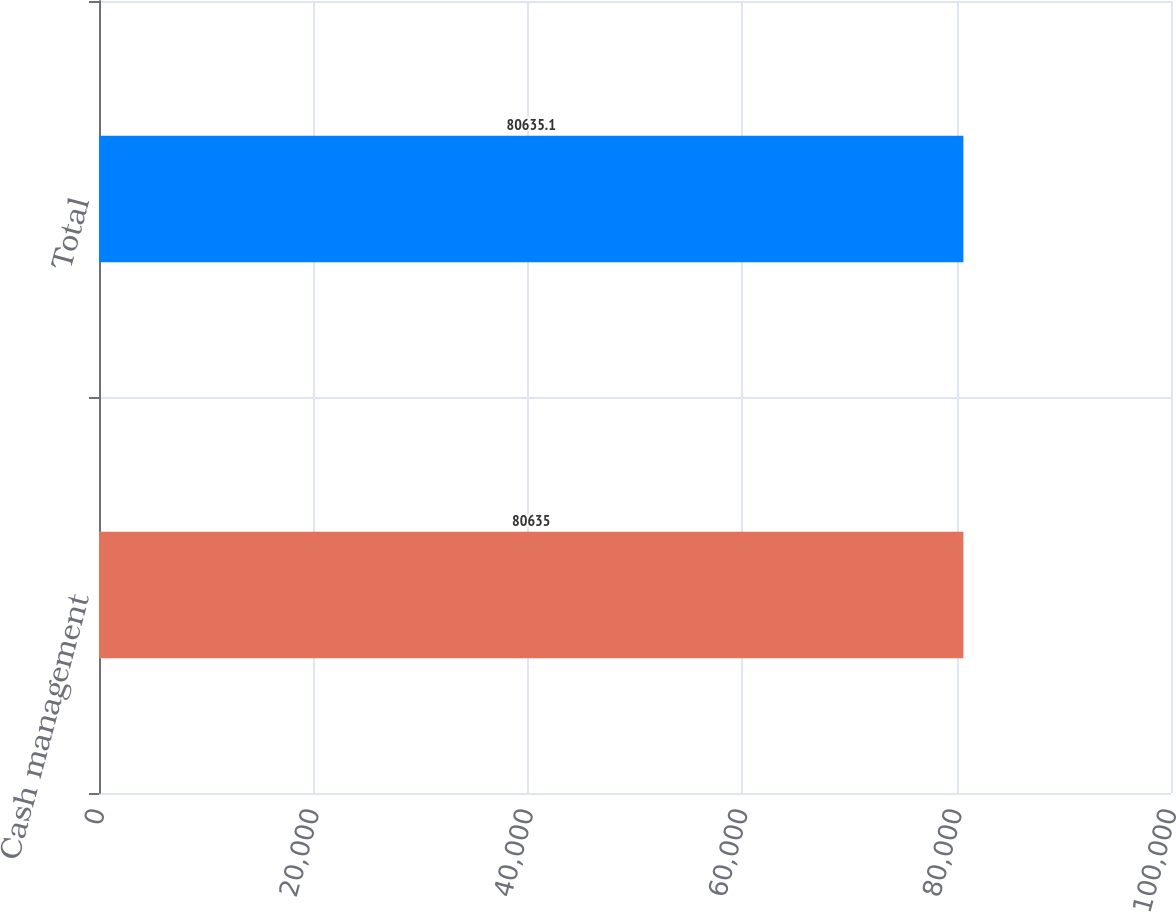Convert chart. <chart><loc_0><loc_0><loc_500><loc_500><bar_chart><fcel>Cash management<fcel>Total<nl><fcel>80635<fcel>80635.1<nl></chart> 